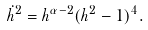<formula> <loc_0><loc_0><loc_500><loc_500>\dot { h } ^ { 2 } = h ^ { \alpha - 2 } ( h ^ { 2 } - 1 ) ^ { 4 } .</formula> 